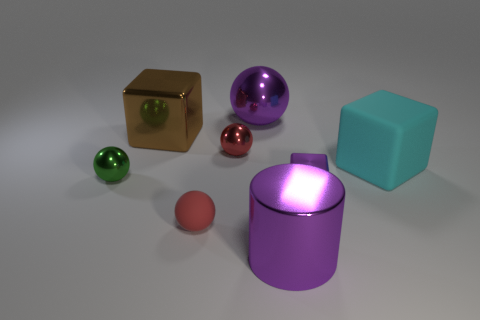Add 1 red metal objects. How many objects exist? 9 Subtract all cylinders. How many objects are left? 7 Add 2 red spheres. How many red spheres are left? 4 Add 5 green matte cubes. How many green matte cubes exist? 5 Subtract 1 green spheres. How many objects are left? 7 Subtract all cubes. Subtract all green metal spheres. How many objects are left? 4 